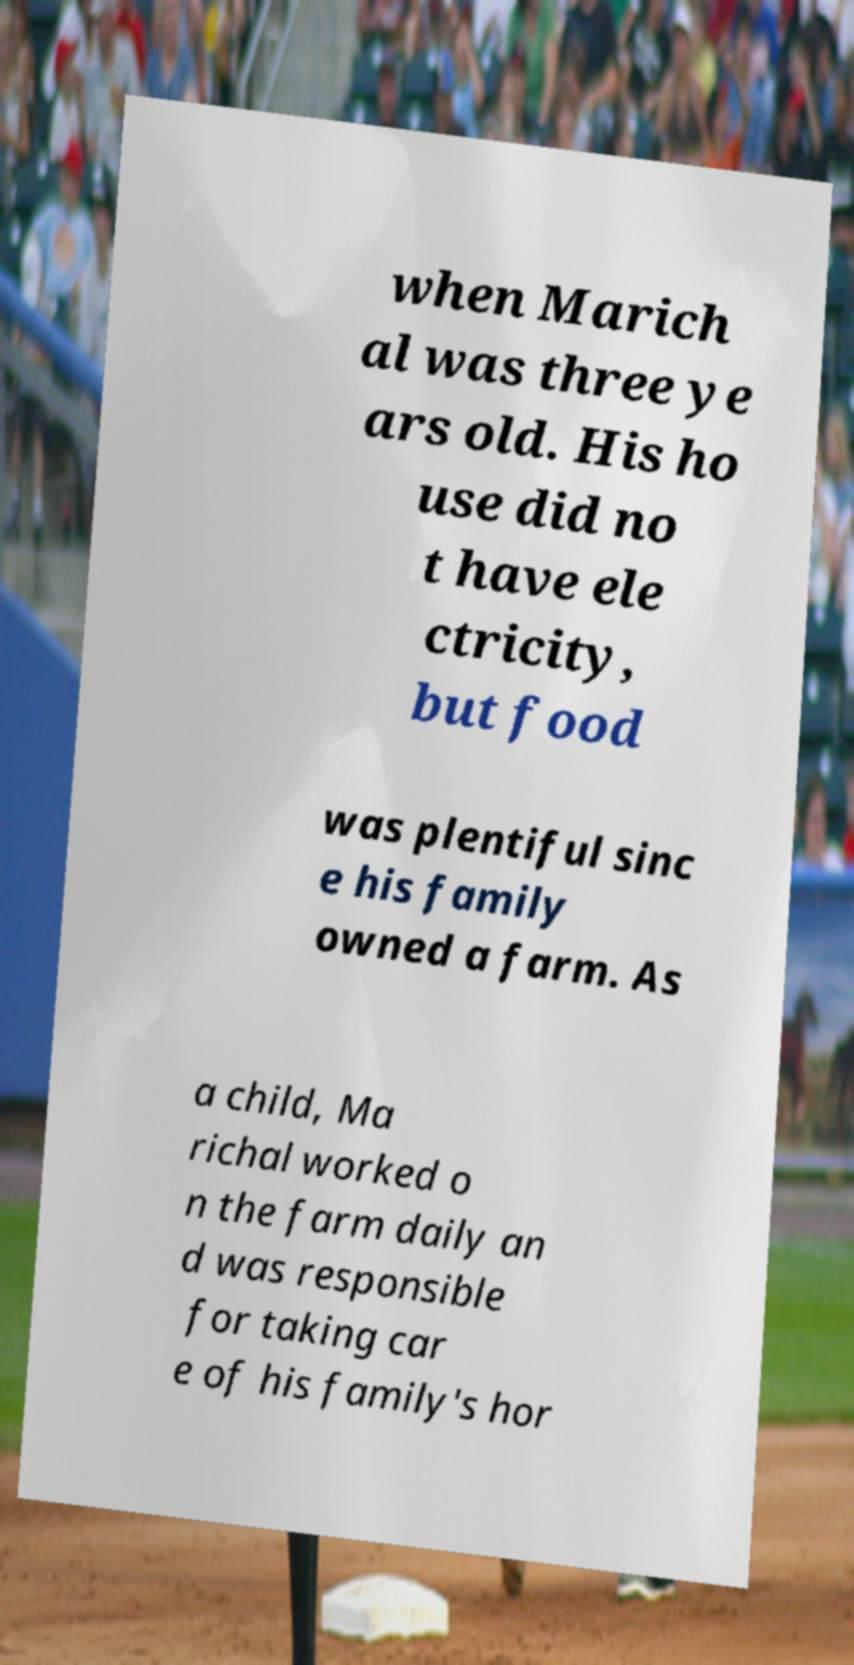What messages or text are displayed in this image? I need them in a readable, typed format. when Marich al was three ye ars old. His ho use did no t have ele ctricity, but food was plentiful sinc e his family owned a farm. As a child, Ma richal worked o n the farm daily an d was responsible for taking car e of his family's hor 